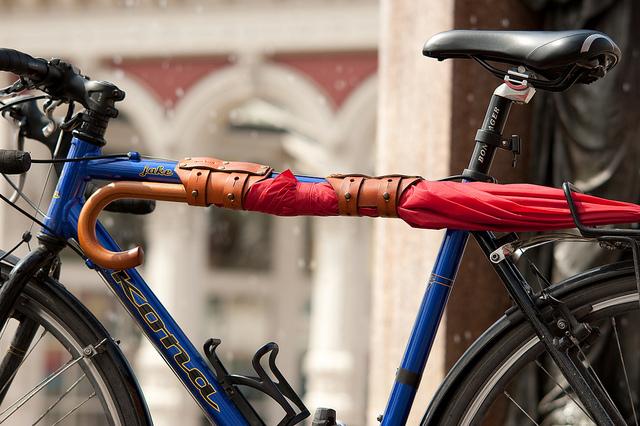What is the umbrella handle made of?
Be succinct. Wood. What is being held on the bike?
Be succinct. Umbrella. Where is the umbrella?
Concise answer only. On bike. 